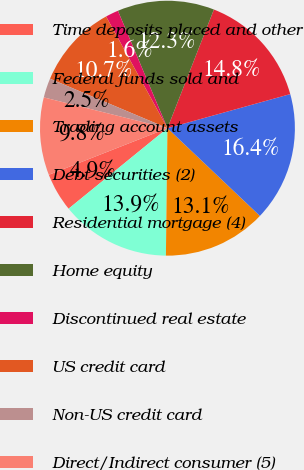Convert chart to OTSL. <chart><loc_0><loc_0><loc_500><loc_500><pie_chart><fcel>Time deposits placed and other<fcel>Federal funds sold and<fcel>Trading account assets<fcel>Debt securities (2)<fcel>Residential mortgage (4)<fcel>Home equity<fcel>Discontinued real estate<fcel>US credit card<fcel>Non-US credit card<fcel>Direct/Indirect consumer (5)<nl><fcel>4.92%<fcel>13.93%<fcel>13.11%<fcel>16.39%<fcel>14.75%<fcel>12.29%<fcel>1.64%<fcel>10.66%<fcel>2.46%<fcel>9.84%<nl></chart> 